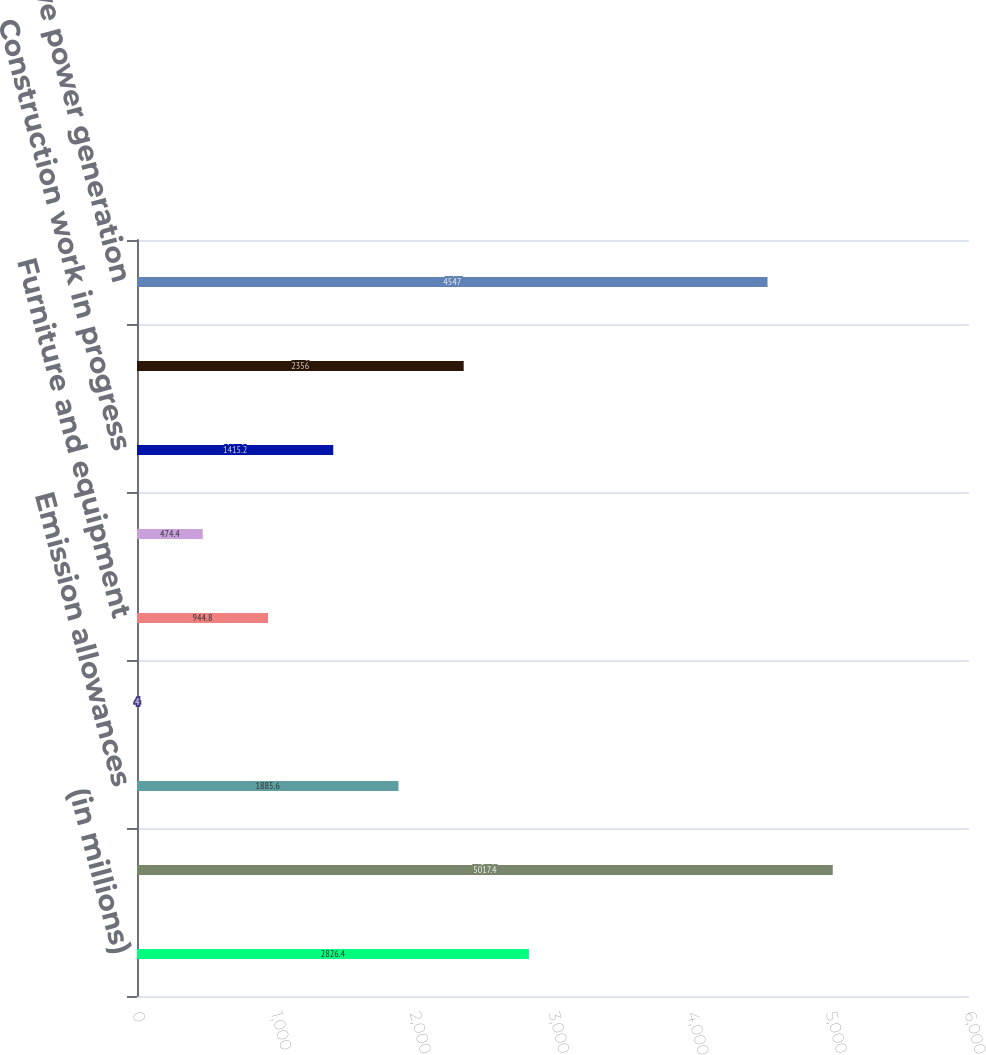<chart> <loc_0><loc_0><loc_500><loc_500><bar_chart><fcel>(in millions)<fcel>Building plant and equipment<fcel>Emission allowances<fcel>Leasehold improvements<fcel>Furniture and equipment<fcel>Land (including easements)<fcel>Construction work in progress<fcel>Accumulated depreciation<fcel>Competitive power generation<nl><fcel>2826.4<fcel>5017.4<fcel>1885.6<fcel>4<fcel>944.8<fcel>474.4<fcel>1415.2<fcel>2356<fcel>4547<nl></chart> 